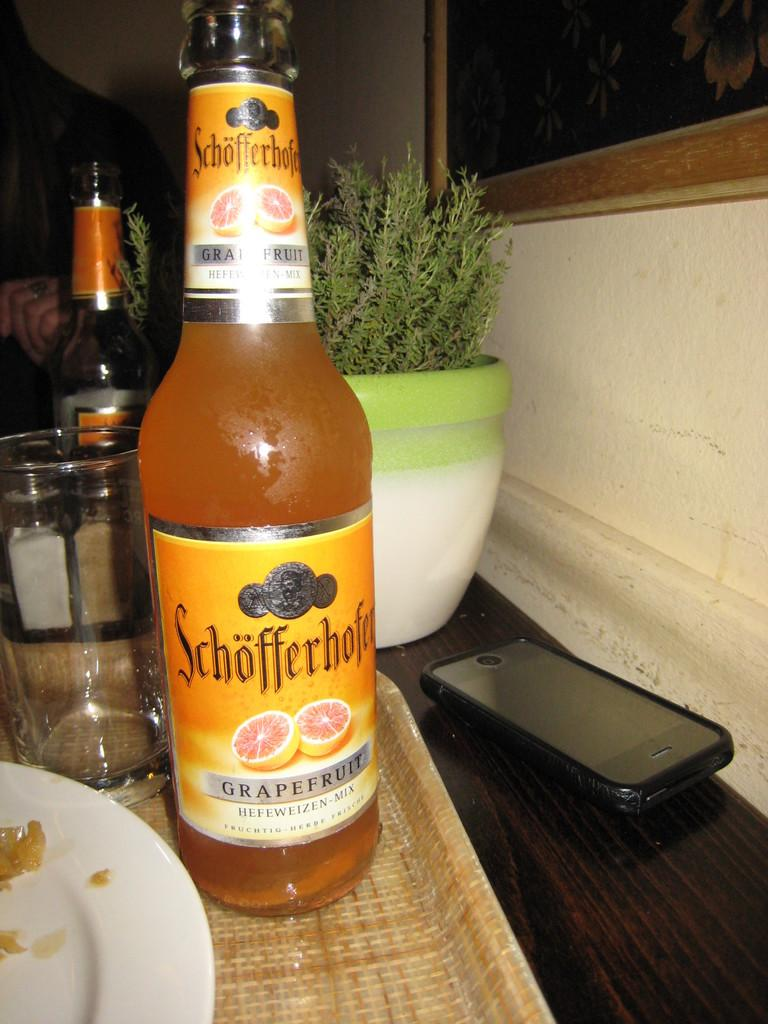What piece of furniture is present in the image? There is a table in the image. What is placed on the table? There is a plate, a wine bottle, a flower pot, a jar, and a mobile on the table. Can you describe the contents of the flower pot? The flower pot contains a plant or flowers, but the specific type cannot be determined from the image. What is the purpose of the jar on the table? The purpose of the jar cannot be determined from the image, but it may be used for holding utensils, condiments, or other items. What type of horn can be seen on the table in the image? There is no horn present on the table in the image. Can you tell me how much the receipt costs for the items on the table? There is no receipt present on the table in the image, so the cost cannot be determined. 